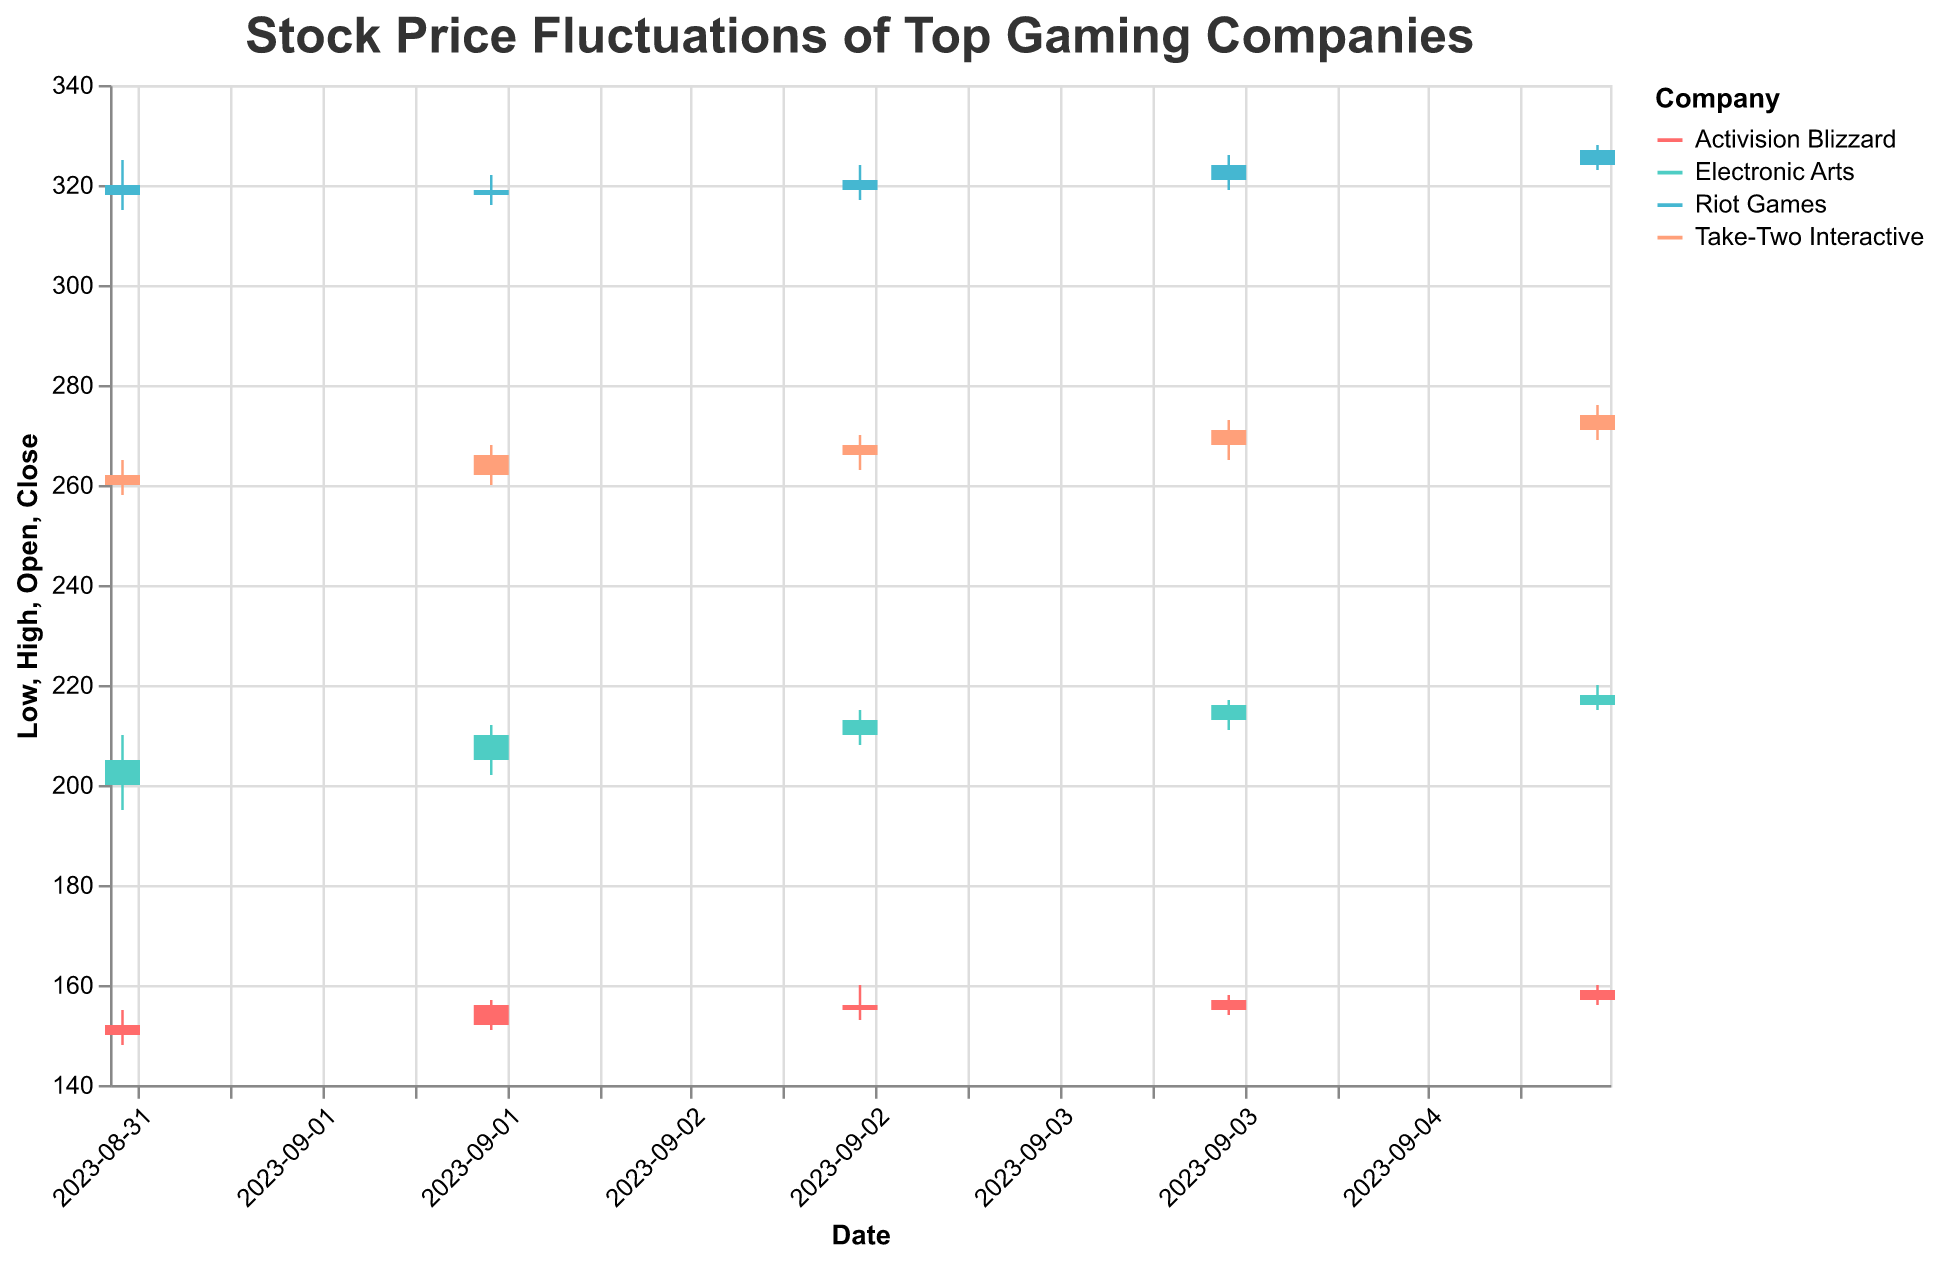What's the title of the figure? The title is written at the top of the figure.
Answer: Stock Price Fluctuations of Top Gaming Companies Which company had the highest closing price on 2023-09-05? Checking the 'Close' prices for all companies on 2023-09-05, Riot Games has the highest closing price of 327.
Answer: Riot Games How did the launch of the new Call of Duty update on 2023-09-01 affect Activision Blizzard’s closing price? Comparing the closing price on 2023-09-01 (152) to the previous day or any available historical price, it indicates the result after the update.
Answer: Closed at 152 What is the difference between the highest and lowest prices for Electronic Arts on 2023-09-03? The highest price on 2023-09-03 is 215, and the lowest is 208. The difference is 215 - 208.
Answer: 7 Which company showed the most significant increase in closing price from 2023-09-01 to 2023-09-05? Comparing the closing prices on 2023-09-01 and 2023-09-05 for each company, the difference for Activision Blizzard (159-152=7), Electronic Arts (218-205=13), Riot Games (327-318=9), Take-Two Interactive (274-262=12).
Answer: Electronic Arts What event corresponds to the highest trading volume for any company? Looking at the 'Volume' values, Riot Games on 2023-09-01 has the highest volume (2000000) related to the League of Legends Worlds Championship announcement.
Answer: League of Legends Worlds Championship announcement How did the favorable earnings report on 2023-09-03 impact Electronic Arts’s stock price? Comparing the closing price before (210 on 2023-09-02) and after the report (213 on 2023-09-03) shows a positive impact.
Answer: Increased by 3 Which key event seems to have the least impact on the closing price of its company's stock? Comparing the key events and the corresponding changes in closing prices, the Esports event controversy on 2023-09-03 for Activision Blizzard (156 to 155) seems to have the least impact.
Answer: Esports event controversy What was the lowest price for Take-Two Interactive on 2023-09-03, and what event occurred that day? The lowest price for Take-Two Interactive on 2023-09-03 is 263, and the event was a strategic acquisition announcement.
Answer: 263, Strategic acquisition announcement 